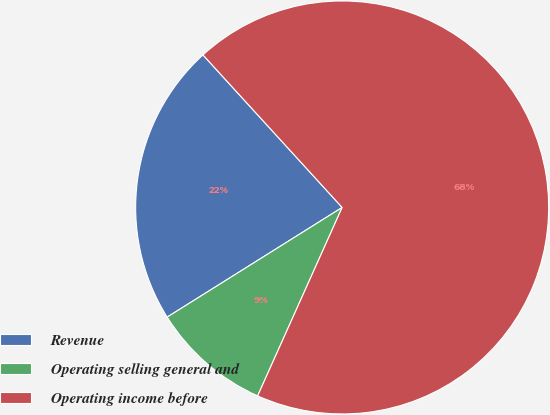Convert chart to OTSL. <chart><loc_0><loc_0><loc_500><loc_500><pie_chart><fcel>Revenue<fcel>Operating selling general and<fcel>Operating income before<nl><fcel>22.14%<fcel>9.38%<fcel>68.49%<nl></chart> 